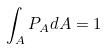<formula> <loc_0><loc_0><loc_500><loc_500>\int _ { A } P _ { A } d A = 1</formula> 